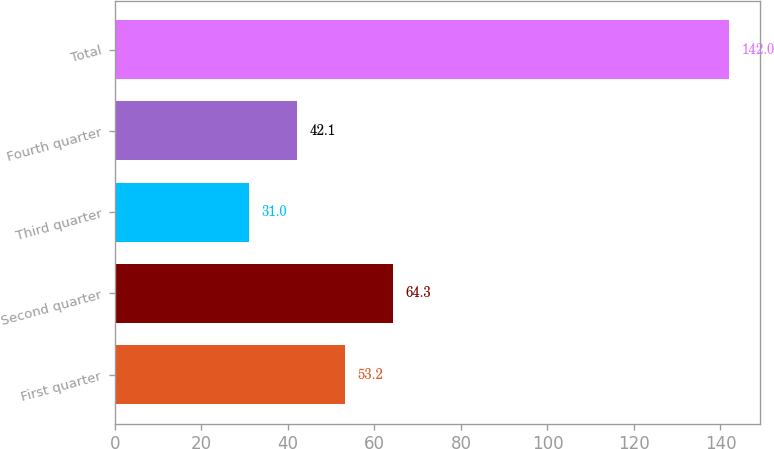Convert chart. <chart><loc_0><loc_0><loc_500><loc_500><bar_chart><fcel>First quarter<fcel>Second quarter<fcel>Third quarter<fcel>Fourth quarter<fcel>Total<nl><fcel>53.2<fcel>64.3<fcel>31<fcel>42.1<fcel>142<nl></chart> 